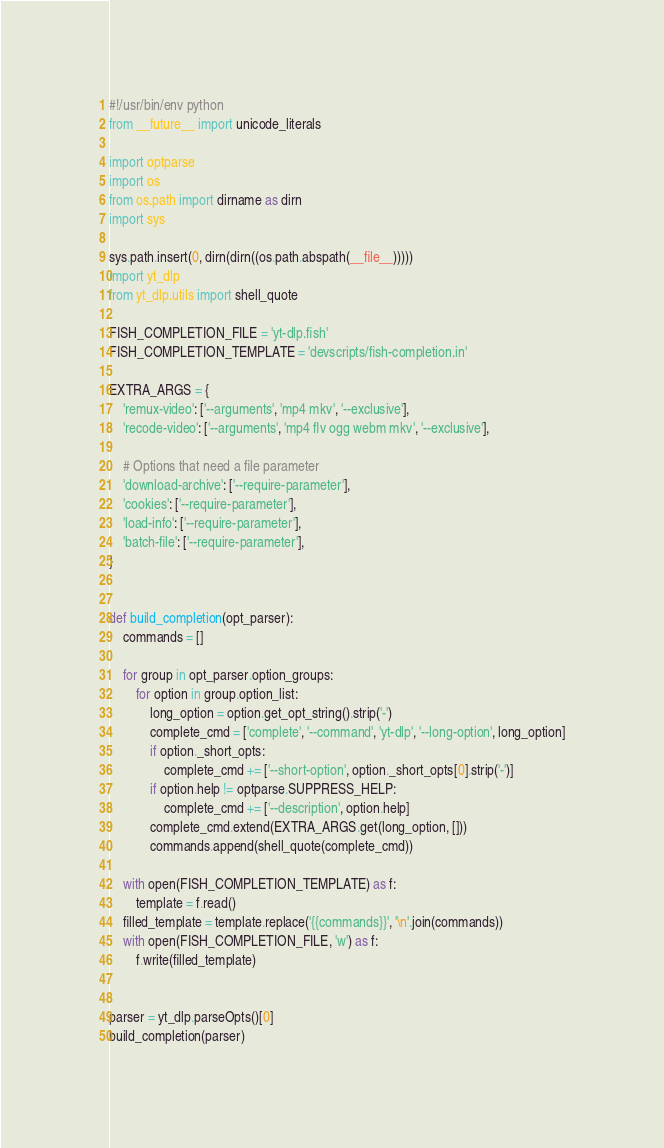<code> <loc_0><loc_0><loc_500><loc_500><_Python_>#!/usr/bin/env python
from __future__ import unicode_literals

import optparse
import os
from os.path import dirname as dirn
import sys

sys.path.insert(0, dirn(dirn((os.path.abspath(__file__)))))
import yt_dlp
from yt_dlp.utils import shell_quote

FISH_COMPLETION_FILE = 'yt-dlp.fish'
FISH_COMPLETION_TEMPLATE = 'devscripts/fish-completion.in'

EXTRA_ARGS = {
    'remux-video': ['--arguments', 'mp4 mkv', '--exclusive'],
    'recode-video': ['--arguments', 'mp4 flv ogg webm mkv', '--exclusive'],

    # Options that need a file parameter
    'download-archive': ['--require-parameter'],
    'cookies': ['--require-parameter'],
    'load-info': ['--require-parameter'],
    'batch-file': ['--require-parameter'],
}


def build_completion(opt_parser):
    commands = []

    for group in opt_parser.option_groups:
        for option in group.option_list:
            long_option = option.get_opt_string().strip('-')
            complete_cmd = ['complete', '--command', 'yt-dlp', '--long-option', long_option]
            if option._short_opts:
                complete_cmd += ['--short-option', option._short_opts[0].strip('-')]
            if option.help != optparse.SUPPRESS_HELP:
                complete_cmd += ['--description', option.help]
            complete_cmd.extend(EXTRA_ARGS.get(long_option, []))
            commands.append(shell_quote(complete_cmd))

    with open(FISH_COMPLETION_TEMPLATE) as f:
        template = f.read()
    filled_template = template.replace('{{commands}}', '\n'.join(commands))
    with open(FISH_COMPLETION_FILE, 'w') as f:
        f.write(filled_template)


parser = yt_dlp.parseOpts()[0]
build_completion(parser)
</code> 